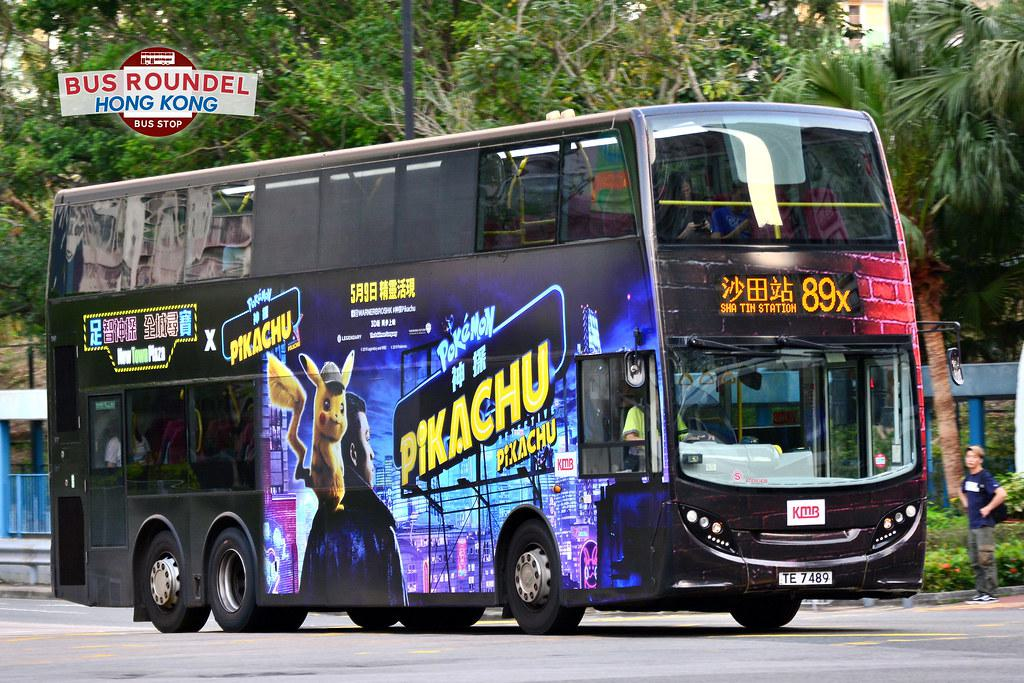What's unusual about the bus in the image? The bus in the image features a colorful advertisement for Pokémon with a large depiction of Pikachu, highlighting a special collaboration or promotional campaign. This kind of vibrant wrapping over public transport isn't a common sight in every city. 